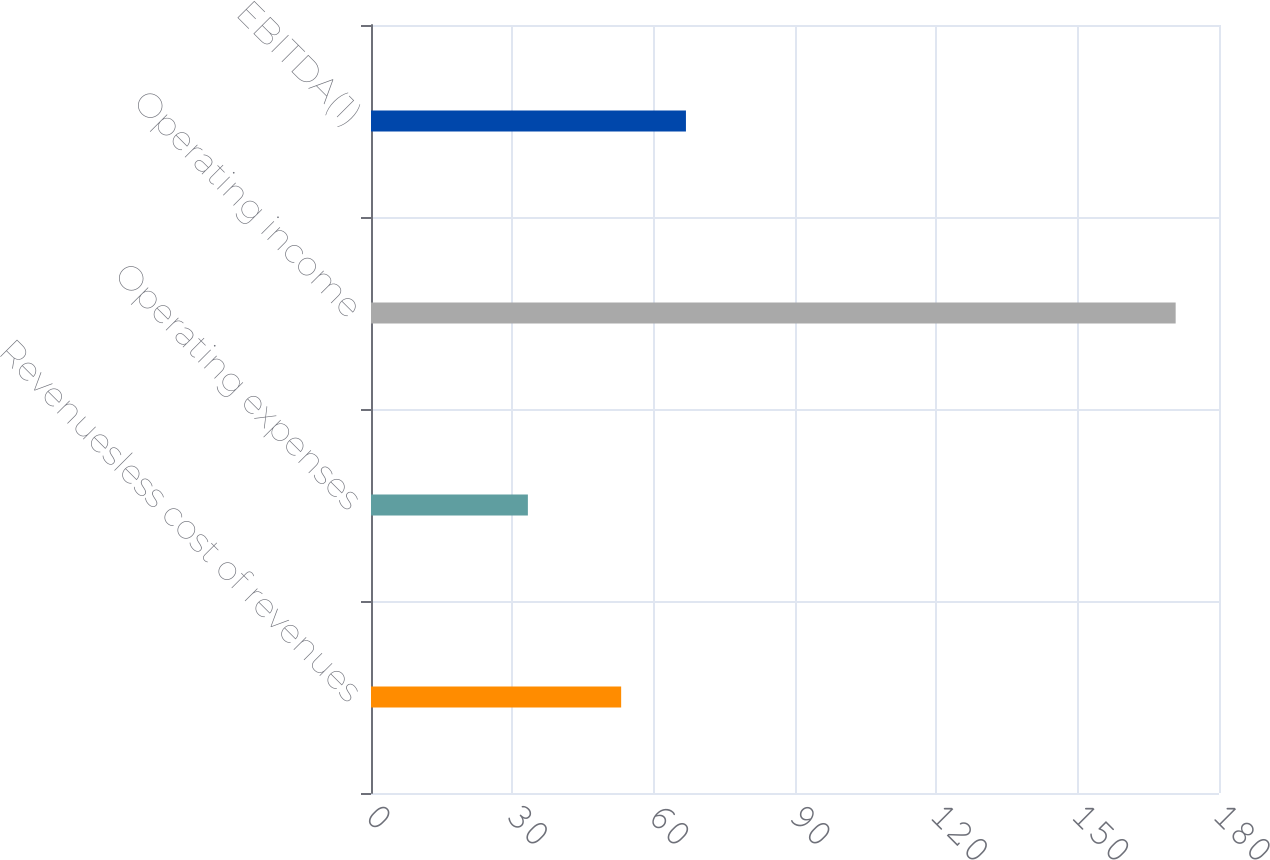Convert chart to OTSL. <chart><loc_0><loc_0><loc_500><loc_500><bar_chart><fcel>Revenuesless cost of revenues<fcel>Operating expenses<fcel>Operating income<fcel>EBITDA(1)<nl><fcel>53.1<fcel>33.3<fcel>170.8<fcel>66.85<nl></chart> 